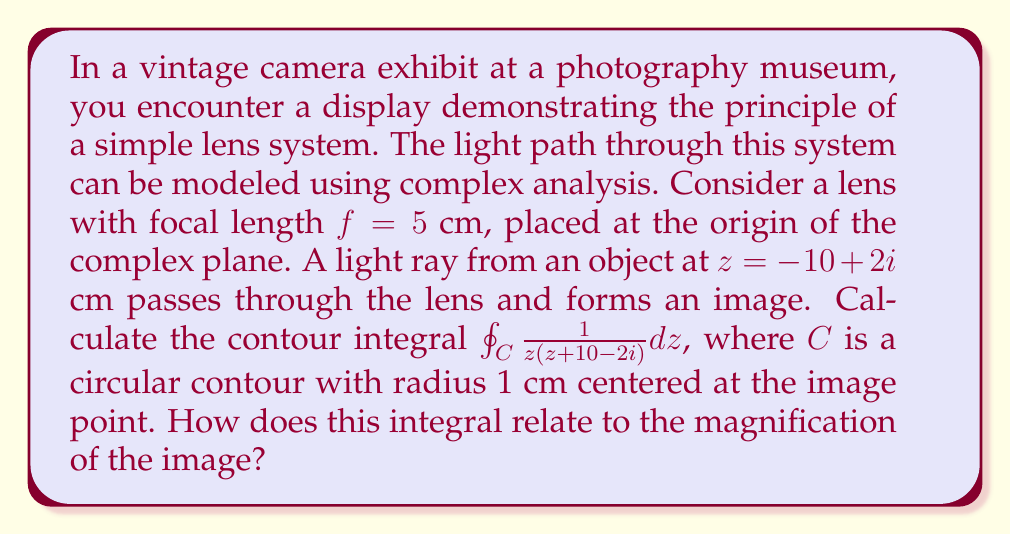Could you help me with this problem? Let's approach this problem step-by-step:

1) First, we need to find the image point. The lens equation in complex form is:

   $$\frac{1}{z_o} + \frac{1}{z_i} = \frac{1}{f}$$

   where $z_o$ is the object position and $z_i$ is the image position.

2) We have $z_o = -10+2i$ and $f = 5$. Substituting:

   $$\frac{1}{-10+2i} + \frac{1}{z_i} = \frac{1}{5}$$

3) Solving for $z_i$:

   $$z_i = \frac{50-10i}{3-i} = \frac{(50-10i)(3+i)}{(3-i)(3+i)} = \frac{140+130i}{10} = 14+13i$$

4) Now, we need to evaluate the contour integral:

   $$\oint_C \frac{1}{z(z+10-2i)} dz$$

5) This integral has two poles: $z=0$ and $z=-10+2i$. The contour $C$ is centered at the image point $14+13i$ with radius 1, so it doesn't enclose either pole.

6) By Cauchy's integral theorem, if a contour doesn't enclose any singularities, the integral around that contour is zero.

7) Therefore, $\oint_C \frac{1}{z(z+10-2i)} dz = 0$

8) The magnification of the image is given by $m = -\frac{z_i}{z_o}$. In this case:

   $$m = -\frac{14+13i}{-10+2i} = -\frac{(14+13i)(-10-2i)}{(-10+2i)(-10-2i)} = \frac{168+106i}{104} \approx 1.62 + 1.02i$$

9) The magnitude of the magnification is $|m| = \sqrt{1.62^2 + 1.02^2} \approx 1.91$

The fact that the contour integral is zero indicates that the image point we calculated is correct, as it doesn't enclose any singularities. The magnification shows that the image is larger than the object and slightly rotated in the complex plane.
Answer: The contour integral $\oint_C \frac{1}{z(z+10-2i)} dz = 0$. This result confirms the correct location of the image point. The magnification of the image is $m \approx 1.62 + 1.02i$ with magnitude $|m| \approx 1.91$, indicating an enlarged and slightly rotated image. 